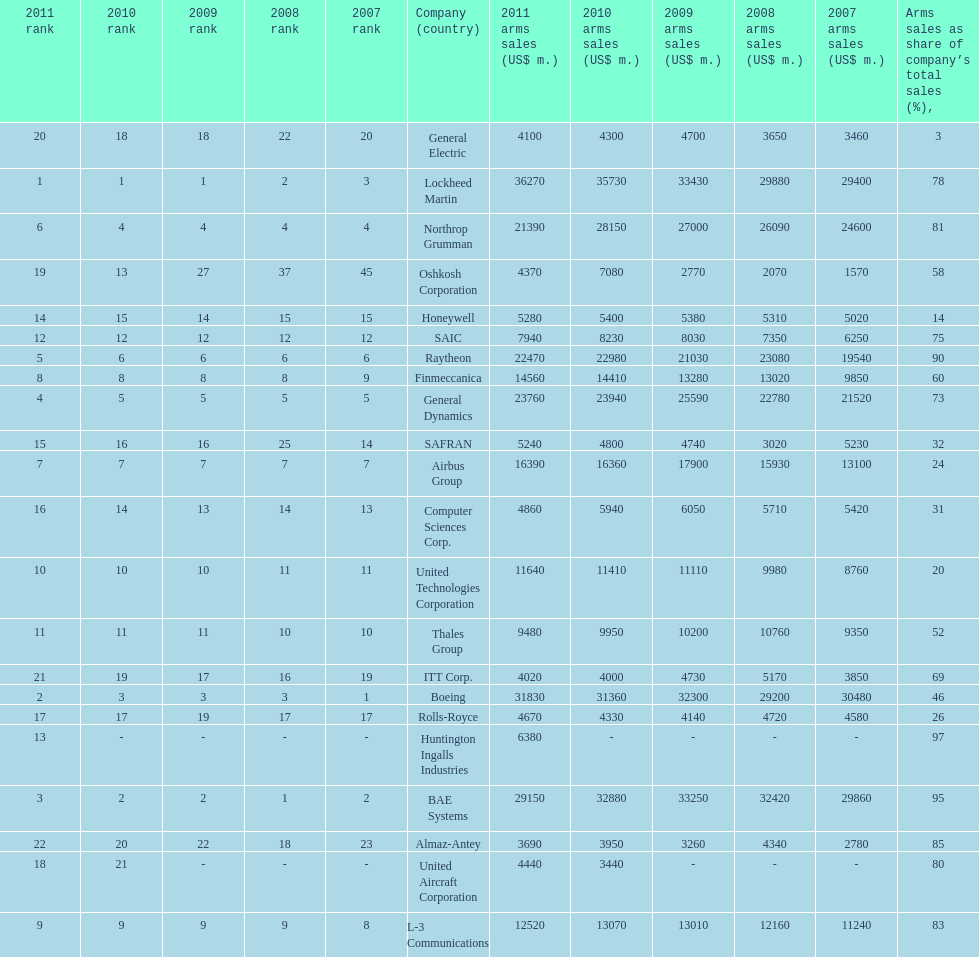Identify all the firms where the proportion of weapons sales to their total revenue falls below 75%. Boeing, General Dynamics, Airbus Group, Finmeccanica, United Technologies Corporation, Thales Group, Honeywell, SAFRAN, Computer Sciences Corp., Rolls-Royce, Oshkosh Corporation, General Electric, ITT Corp. 